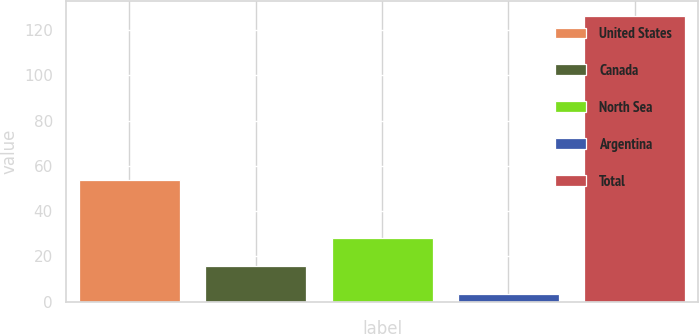Convert chart to OTSL. <chart><loc_0><loc_0><loc_500><loc_500><bar_chart><fcel>United States<fcel>Canada<fcel>North Sea<fcel>Argentina<fcel>Total<nl><fcel>53.6<fcel>15.71<fcel>28.02<fcel>3.4<fcel>126.5<nl></chart> 